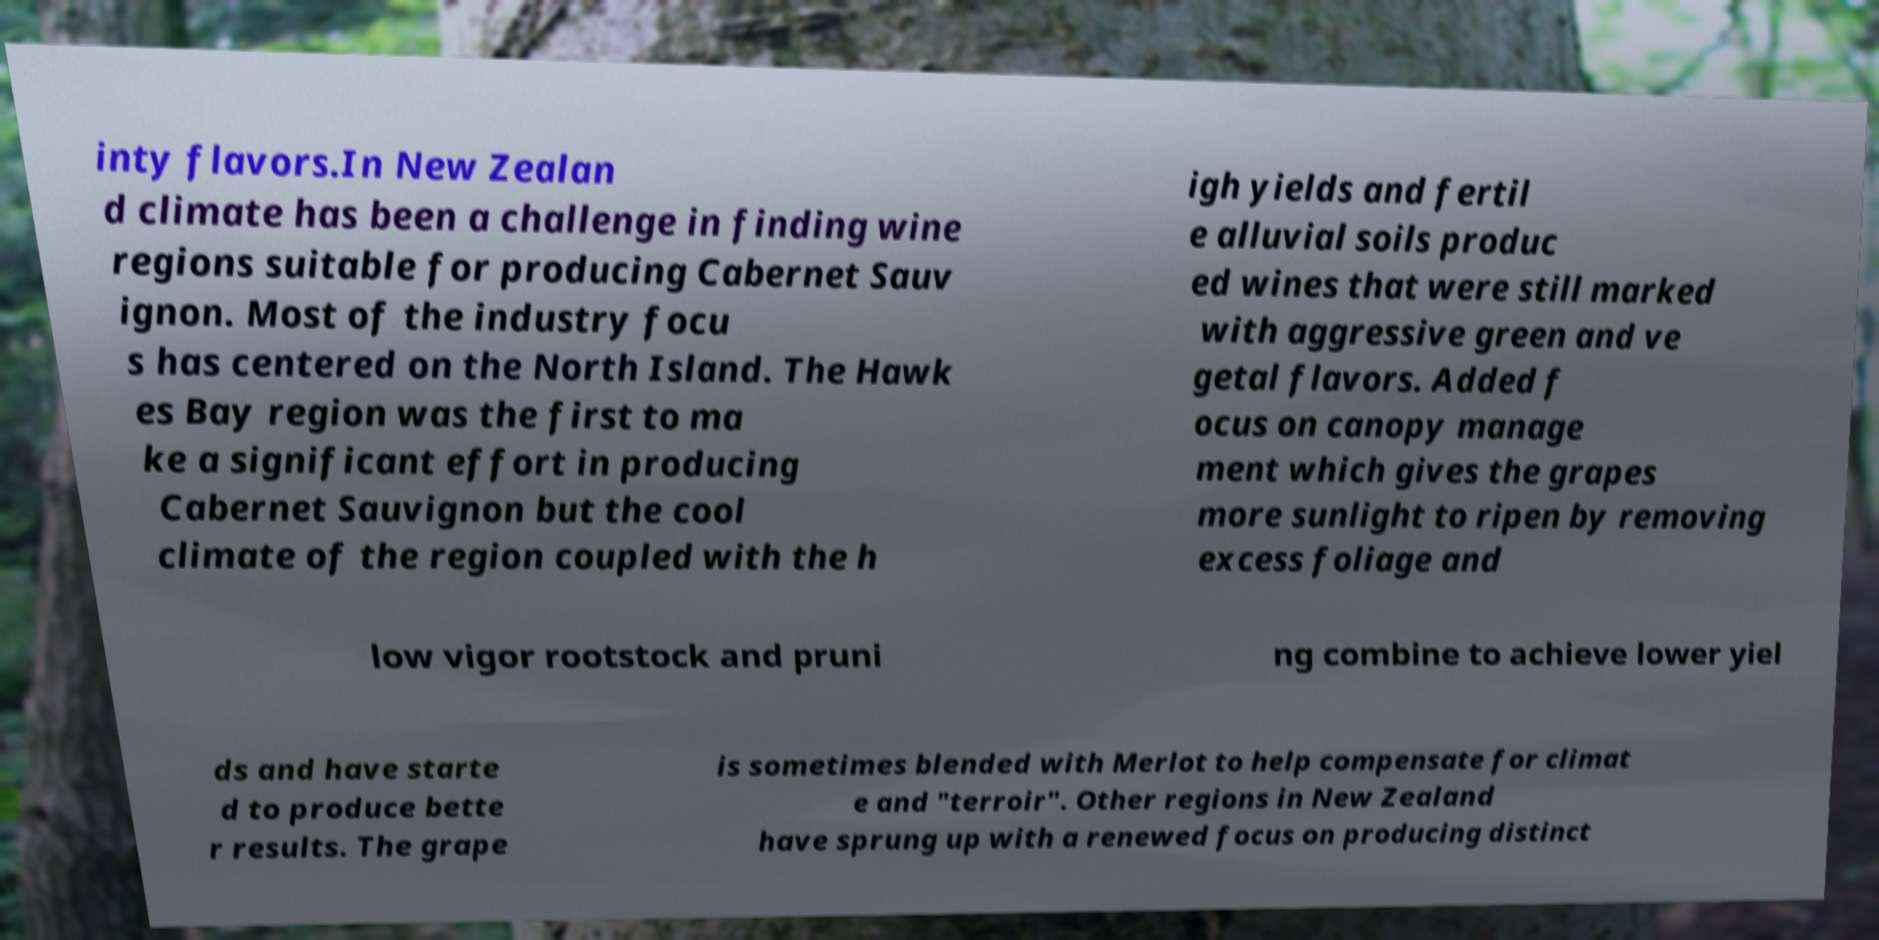What messages or text are displayed in this image? I need them in a readable, typed format. inty flavors.In New Zealan d climate has been a challenge in finding wine regions suitable for producing Cabernet Sauv ignon. Most of the industry focu s has centered on the North Island. The Hawk es Bay region was the first to ma ke a significant effort in producing Cabernet Sauvignon but the cool climate of the region coupled with the h igh yields and fertil e alluvial soils produc ed wines that were still marked with aggressive green and ve getal flavors. Added f ocus on canopy manage ment which gives the grapes more sunlight to ripen by removing excess foliage and low vigor rootstock and pruni ng combine to achieve lower yiel ds and have starte d to produce bette r results. The grape is sometimes blended with Merlot to help compensate for climat e and "terroir". Other regions in New Zealand have sprung up with a renewed focus on producing distinct 